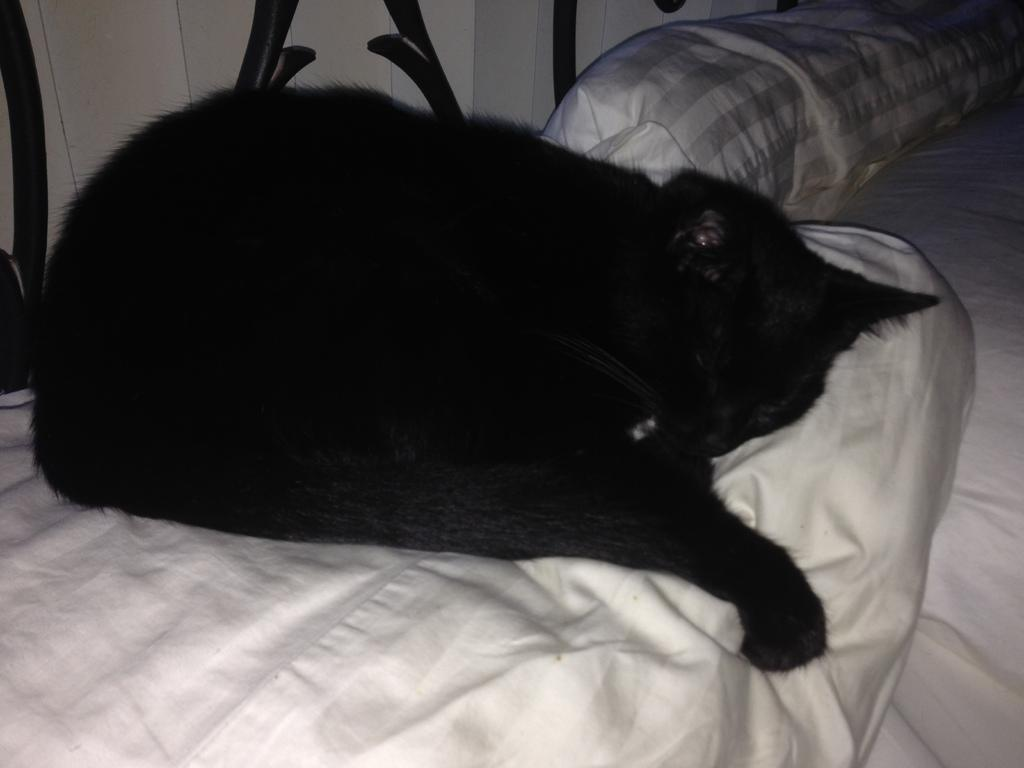What type of animal is in the image? There is a black cat in the image. What is the cat doing in the image? The cat is sleeping on a pillow. What piece of furniture is present in the image? There is a bed in the image. What color is the grill visible in the image? The grill in the image is black. What architectural feature can be seen in the image? There is a wall visible in the image. Where is the root of the tree located in the image? There is no tree present in the image, so there is no root to be found. 